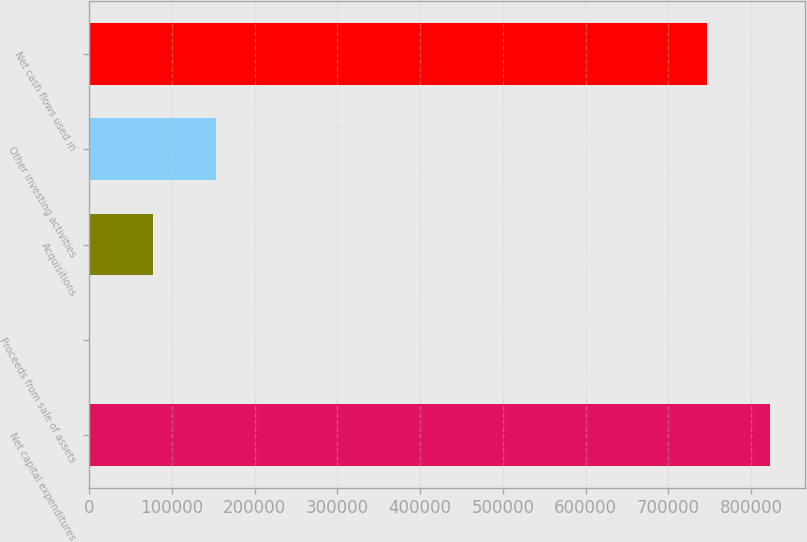Convert chart. <chart><loc_0><loc_0><loc_500><loc_500><bar_chart><fcel>Net capital expenditures<fcel>Proceeds from sale of assets<fcel>Acquisitions<fcel>Other investing activities<fcel>Net cash flows used in<nl><fcel>823283<fcel>239<fcel>76778.7<fcel>153318<fcel>746743<nl></chart> 